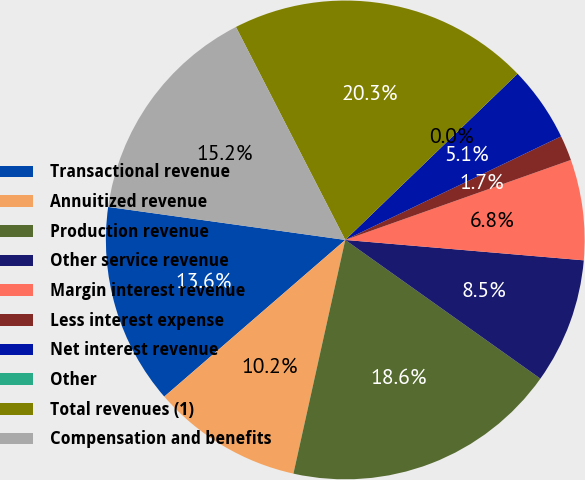<chart> <loc_0><loc_0><loc_500><loc_500><pie_chart><fcel>Transactional revenue<fcel>Annuitized revenue<fcel>Production revenue<fcel>Other service revenue<fcel>Margin interest revenue<fcel>Less interest expense<fcel>Net interest revenue<fcel>Other<fcel>Total revenues (1)<fcel>Compensation and benefits<nl><fcel>13.56%<fcel>10.17%<fcel>18.64%<fcel>8.48%<fcel>6.78%<fcel>1.7%<fcel>5.09%<fcel>0.0%<fcel>20.34%<fcel>15.25%<nl></chart> 